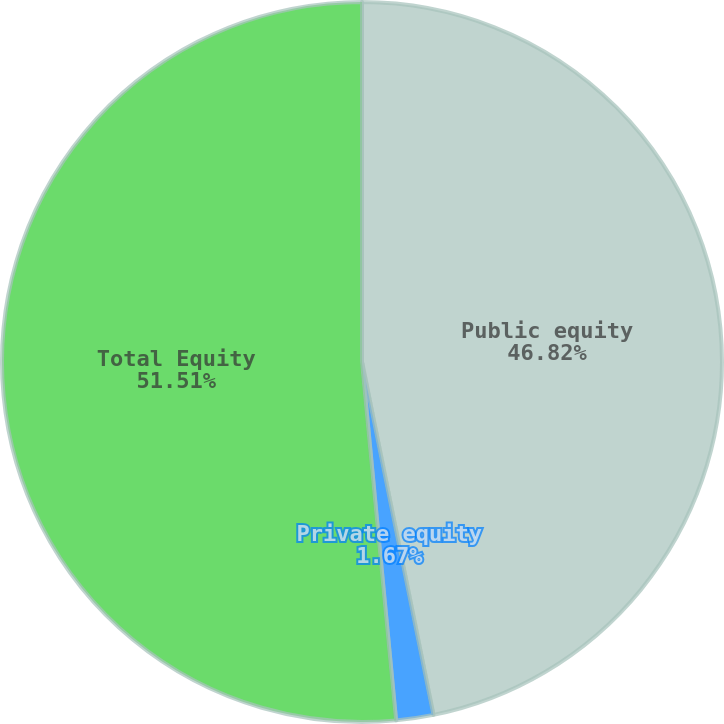Convert chart. <chart><loc_0><loc_0><loc_500><loc_500><pie_chart><fcel>Public equity<fcel>Private equity<fcel>Total Equity<nl><fcel>46.82%<fcel>1.67%<fcel>51.51%<nl></chart> 